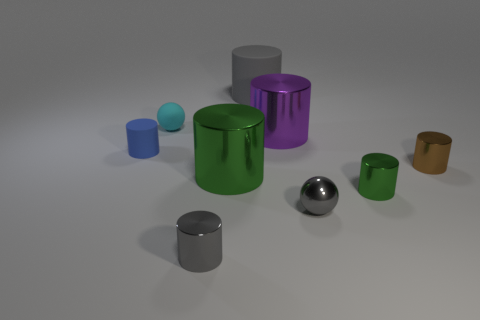Subtract 2 cylinders. How many cylinders are left? 5 Subtract all tiny green metal cylinders. How many cylinders are left? 6 Subtract all gray cylinders. How many cylinders are left? 5 Subtract all cyan cylinders. Subtract all red balls. How many cylinders are left? 7 Add 1 big gray blocks. How many objects exist? 10 Subtract all spheres. How many objects are left? 7 Add 7 small brown cylinders. How many small brown cylinders exist? 8 Subtract 0 yellow cylinders. How many objects are left? 9 Subtract all small brown matte cubes. Subtract all gray things. How many objects are left? 6 Add 2 gray metallic balls. How many gray metallic balls are left? 3 